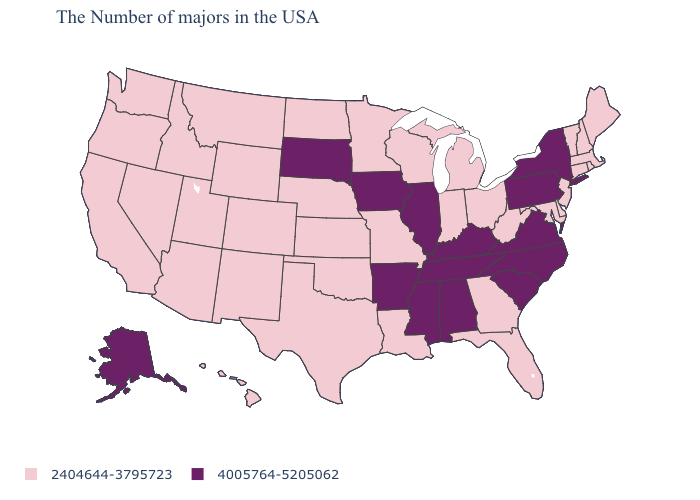Which states have the lowest value in the South?
Write a very short answer. Delaware, Maryland, West Virginia, Florida, Georgia, Louisiana, Oklahoma, Texas. Name the states that have a value in the range 4005764-5205062?
Quick response, please. New York, Pennsylvania, Virginia, North Carolina, South Carolina, Kentucky, Alabama, Tennessee, Illinois, Mississippi, Arkansas, Iowa, South Dakota, Alaska. What is the highest value in the USA?
Be succinct. 4005764-5205062. What is the highest value in the USA?
Give a very brief answer. 4005764-5205062. What is the value of Illinois?
Give a very brief answer. 4005764-5205062. Does the first symbol in the legend represent the smallest category?
Quick response, please. Yes. Among the states that border West Virginia , does Pennsylvania have the lowest value?
Give a very brief answer. No. Among the states that border Wisconsin , which have the lowest value?
Answer briefly. Michigan, Minnesota. Does Alaska have the highest value in the West?
Be succinct. Yes. Which states have the lowest value in the West?
Give a very brief answer. Wyoming, Colorado, New Mexico, Utah, Montana, Arizona, Idaho, Nevada, California, Washington, Oregon, Hawaii. Does New Jersey have a higher value than Arkansas?
Short answer required. No. What is the value of Georgia?
Concise answer only. 2404644-3795723. What is the lowest value in the South?
Keep it brief. 2404644-3795723. Which states have the highest value in the USA?
Short answer required. New York, Pennsylvania, Virginia, North Carolina, South Carolina, Kentucky, Alabama, Tennessee, Illinois, Mississippi, Arkansas, Iowa, South Dakota, Alaska. Does Vermont have the same value as Hawaii?
Keep it brief. Yes. 